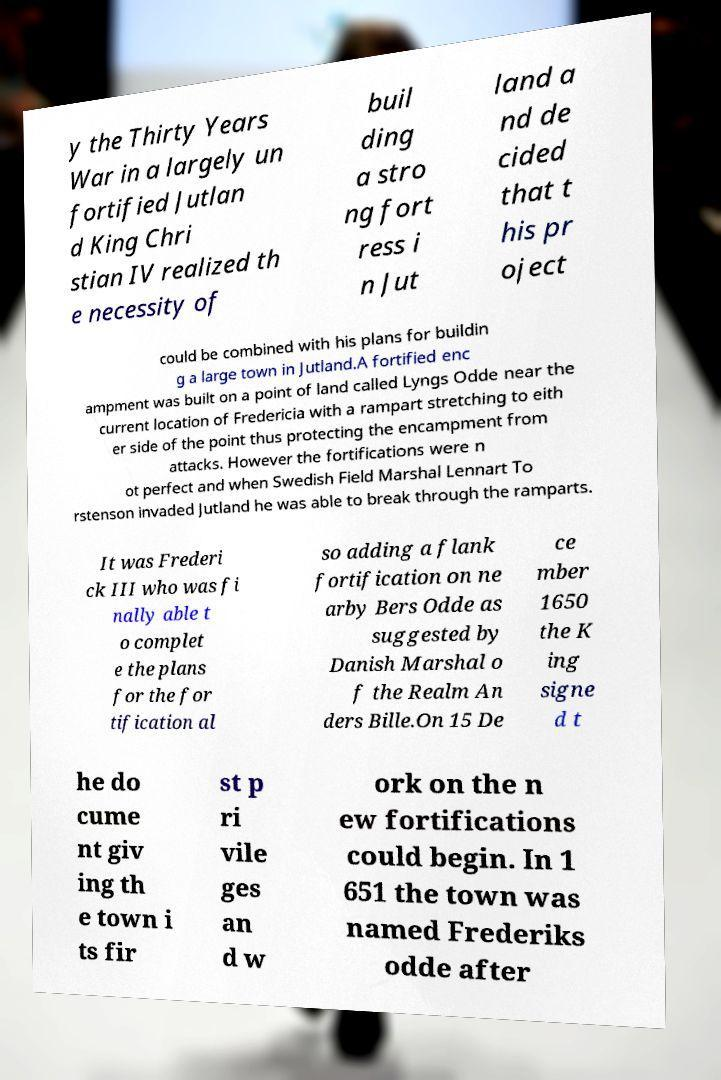For documentation purposes, I need the text within this image transcribed. Could you provide that? y the Thirty Years War in a largely un fortified Jutlan d King Chri stian IV realized th e necessity of buil ding a stro ng fort ress i n Jut land a nd de cided that t his pr oject could be combined with his plans for buildin g a large town in Jutland.A fortified enc ampment was built on a point of land called Lyngs Odde near the current location of Fredericia with a rampart stretching to eith er side of the point thus protecting the encampment from attacks. However the fortifications were n ot perfect and when Swedish Field Marshal Lennart To rstenson invaded Jutland he was able to break through the ramparts. It was Frederi ck III who was fi nally able t o complet e the plans for the for tification al so adding a flank fortification on ne arby Bers Odde as suggested by Danish Marshal o f the Realm An ders Bille.On 15 De ce mber 1650 the K ing signe d t he do cume nt giv ing th e town i ts fir st p ri vile ges an d w ork on the n ew fortifications could begin. In 1 651 the town was named Frederiks odde after 